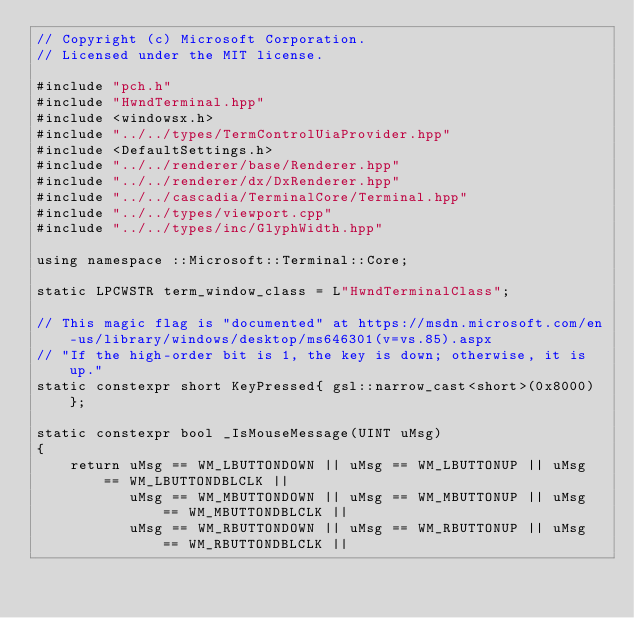<code> <loc_0><loc_0><loc_500><loc_500><_C++_>// Copyright (c) Microsoft Corporation.
// Licensed under the MIT license.

#include "pch.h"
#include "HwndTerminal.hpp"
#include <windowsx.h>
#include "../../types/TermControlUiaProvider.hpp"
#include <DefaultSettings.h>
#include "../../renderer/base/Renderer.hpp"
#include "../../renderer/dx/DxRenderer.hpp"
#include "../../cascadia/TerminalCore/Terminal.hpp"
#include "../../types/viewport.cpp"
#include "../../types/inc/GlyphWidth.hpp"

using namespace ::Microsoft::Terminal::Core;

static LPCWSTR term_window_class = L"HwndTerminalClass";

// This magic flag is "documented" at https://msdn.microsoft.com/en-us/library/windows/desktop/ms646301(v=vs.85).aspx
// "If the high-order bit is 1, the key is down; otherwise, it is up."
static constexpr short KeyPressed{ gsl::narrow_cast<short>(0x8000) };

static constexpr bool _IsMouseMessage(UINT uMsg)
{
    return uMsg == WM_LBUTTONDOWN || uMsg == WM_LBUTTONUP || uMsg == WM_LBUTTONDBLCLK ||
           uMsg == WM_MBUTTONDOWN || uMsg == WM_MBUTTONUP || uMsg == WM_MBUTTONDBLCLK ||
           uMsg == WM_RBUTTONDOWN || uMsg == WM_RBUTTONUP || uMsg == WM_RBUTTONDBLCLK ||</code> 